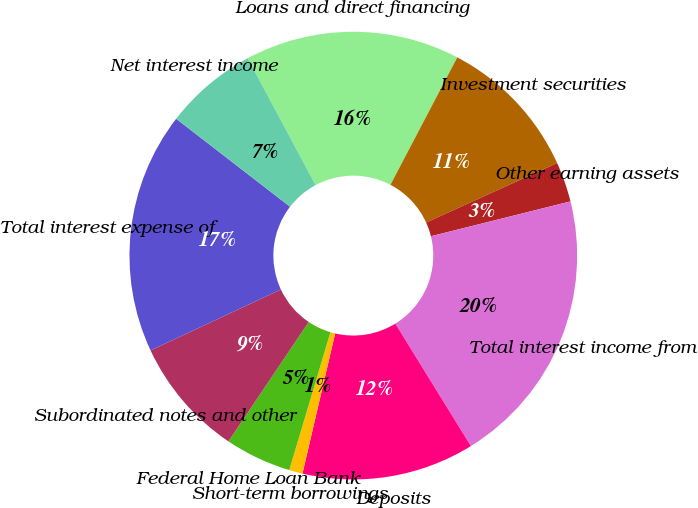Convert chart. <chart><loc_0><loc_0><loc_500><loc_500><pie_chart><fcel>Loans and direct financing<fcel>Investment securities<fcel>Other earning assets<fcel>Total interest income from<fcel>Deposits<fcel>Short-term borrowings<fcel>Federal Home Loan Bank<fcel>Subordinated notes and other<fcel>Total interest expense of<fcel>Net interest income<nl><fcel>15.51%<fcel>10.53%<fcel>2.89%<fcel>20.09%<fcel>12.45%<fcel>0.97%<fcel>4.8%<fcel>8.62%<fcel>17.43%<fcel>6.71%<nl></chart> 